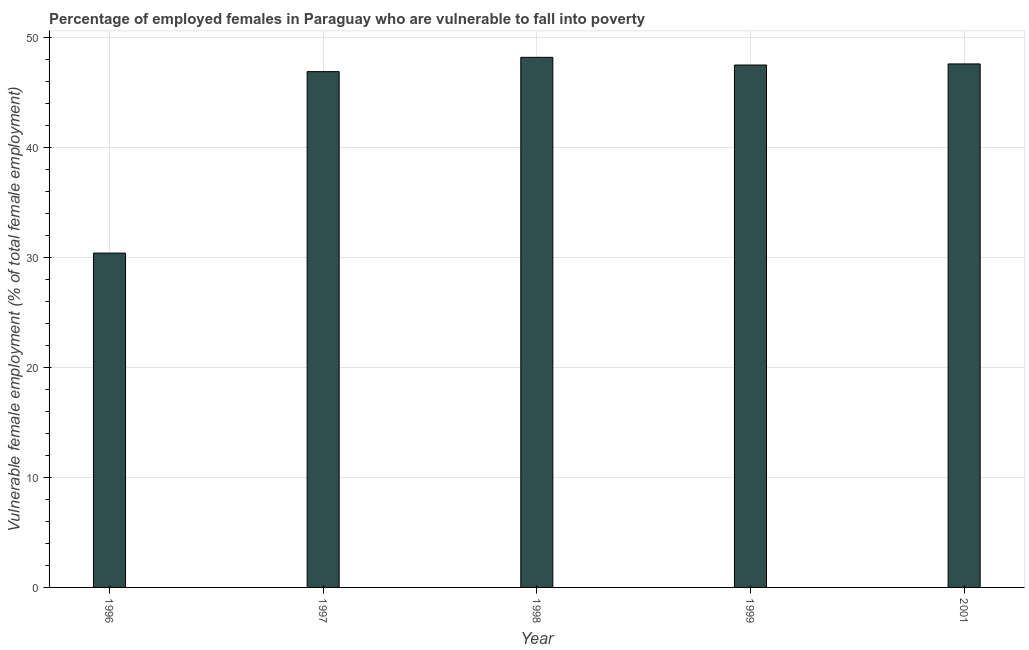Does the graph contain grids?
Your response must be concise. Yes. What is the title of the graph?
Give a very brief answer. Percentage of employed females in Paraguay who are vulnerable to fall into poverty. What is the label or title of the Y-axis?
Give a very brief answer. Vulnerable female employment (% of total female employment). What is the percentage of employed females who are vulnerable to fall into poverty in 1997?
Ensure brevity in your answer.  46.9. Across all years, what is the maximum percentage of employed females who are vulnerable to fall into poverty?
Provide a succinct answer. 48.2. Across all years, what is the minimum percentage of employed females who are vulnerable to fall into poverty?
Provide a succinct answer. 30.4. What is the sum of the percentage of employed females who are vulnerable to fall into poverty?
Make the answer very short. 220.6. What is the difference between the percentage of employed females who are vulnerable to fall into poverty in 1998 and 2001?
Provide a succinct answer. 0.6. What is the average percentage of employed females who are vulnerable to fall into poverty per year?
Your answer should be compact. 44.12. What is the median percentage of employed females who are vulnerable to fall into poverty?
Give a very brief answer. 47.5. Do a majority of the years between 1999 and 1996 (inclusive) have percentage of employed females who are vulnerable to fall into poverty greater than 22 %?
Keep it short and to the point. Yes. Is the percentage of employed females who are vulnerable to fall into poverty in 1998 less than that in 1999?
Offer a very short reply. No. What is the difference between the highest and the second highest percentage of employed females who are vulnerable to fall into poverty?
Provide a short and direct response. 0.6. Is the sum of the percentage of employed females who are vulnerable to fall into poverty in 1996 and 1999 greater than the maximum percentage of employed females who are vulnerable to fall into poverty across all years?
Your response must be concise. Yes. What is the difference between the highest and the lowest percentage of employed females who are vulnerable to fall into poverty?
Your answer should be very brief. 17.8. In how many years, is the percentage of employed females who are vulnerable to fall into poverty greater than the average percentage of employed females who are vulnerable to fall into poverty taken over all years?
Your answer should be very brief. 4. How many bars are there?
Give a very brief answer. 5. What is the difference between two consecutive major ticks on the Y-axis?
Your response must be concise. 10. Are the values on the major ticks of Y-axis written in scientific E-notation?
Give a very brief answer. No. What is the Vulnerable female employment (% of total female employment) of 1996?
Provide a succinct answer. 30.4. What is the Vulnerable female employment (% of total female employment) of 1997?
Ensure brevity in your answer.  46.9. What is the Vulnerable female employment (% of total female employment) of 1998?
Your response must be concise. 48.2. What is the Vulnerable female employment (% of total female employment) in 1999?
Make the answer very short. 47.5. What is the Vulnerable female employment (% of total female employment) in 2001?
Provide a succinct answer. 47.6. What is the difference between the Vulnerable female employment (% of total female employment) in 1996 and 1997?
Offer a very short reply. -16.5. What is the difference between the Vulnerable female employment (% of total female employment) in 1996 and 1998?
Ensure brevity in your answer.  -17.8. What is the difference between the Vulnerable female employment (% of total female employment) in 1996 and 1999?
Give a very brief answer. -17.1. What is the difference between the Vulnerable female employment (% of total female employment) in 1996 and 2001?
Give a very brief answer. -17.2. What is the difference between the Vulnerable female employment (% of total female employment) in 1997 and 1998?
Offer a terse response. -1.3. What is the difference between the Vulnerable female employment (% of total female employment) in 1997 and 1999?
Offer a very short reply. -0.6. What is the difference between the Vulnerable female employment (% of total female employment) in 1999 and 2001?
Offer a very short reply. -0.1. What is the ratio of the Vulnerable female employment (% of total female employment) in 1996 to that in 1997?
Offer a very short reply. 0.65. What is the ratio of the Vulnerable female employment (% of total female employment) in 1996 to that in 1998?
Give a very brief answer. 0.63. What is the ratio of the Vulnerable female employment (% of total female employment) in 1996 to that in 1999?
Your answer should be compact. 0.64. What is the ratio of the Vulnerable female employment (% of total female employment) in 1996 to that in 2001?
Your response must be concise. 0.64. What is the ratio of the Vulnerable female employment (% of total female employment) in 1998 to that in 1999?
Offer a terse response. 1.01. What is the ratio of the Vulnerable female employment (% of total female employment) in 1998 to that in 2001?
Give a very brief answer. 1.01. What is the ratio of the Vulnerable female employment (% of total female employment) in 1999 to that in 2001?
Your response must be concise. 1. 